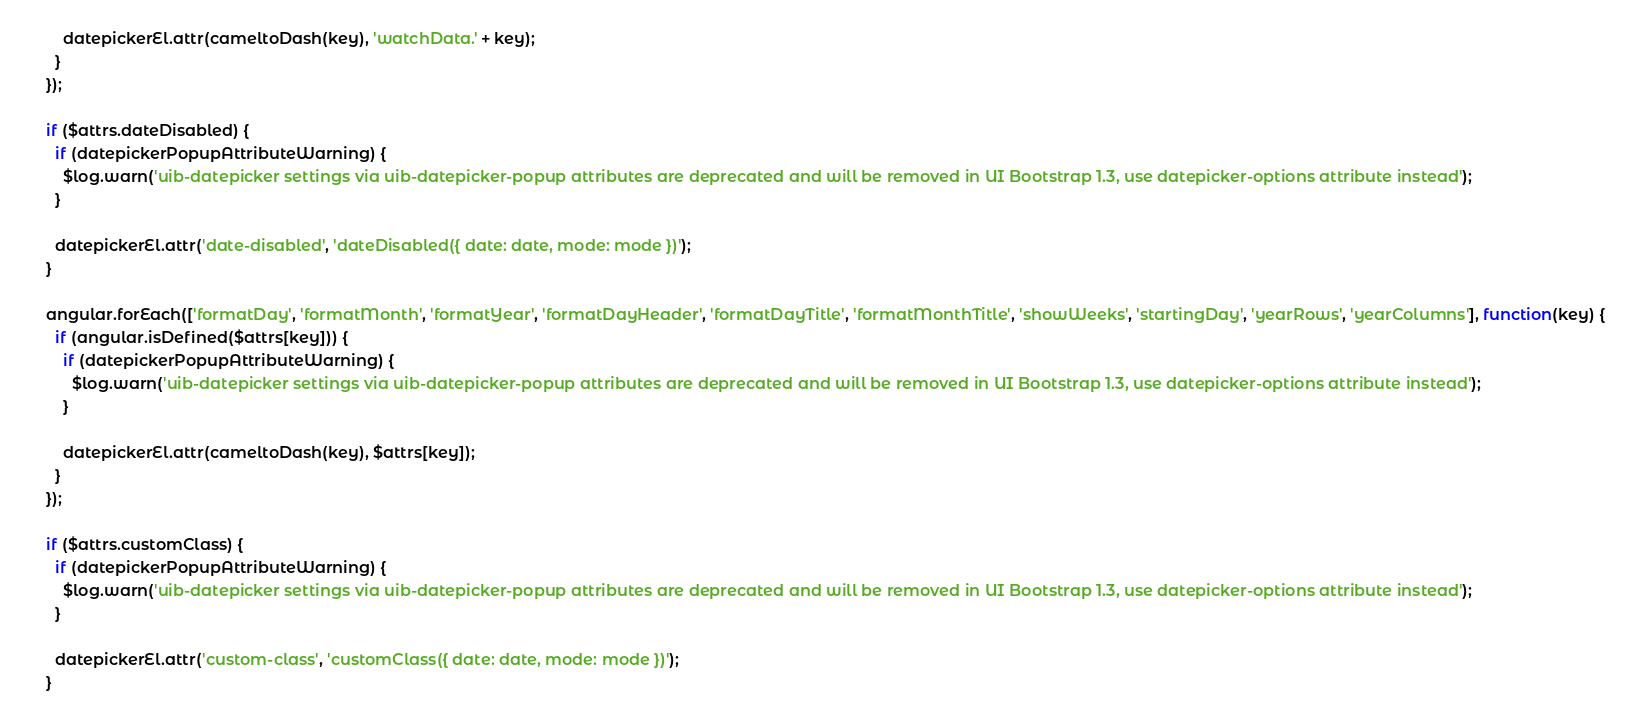<code> <loc_0><loc_0><loc_500><loc_500><_JavaScript_>        datepickerEl.attr(cameltoDash(key), 'watchData.' + key);
      }
    });

    if ($attrs.dateDisabled) {
      if (datepickerPopupAttributeWarning) {
        $log.warn('uib-datepicker settings via uib-datepicker-popup attributes are deprecated and will be removed in UI Bootstrap 1.3, use datepicker-options attribute instead');
      }

      datepickerEl.attr('date-disabled', 'dateDisabled({ date: date, mode: mode })');
    }

    angular.forEach(['formatDay', 'formatMonth', 'formatYear', 'formatDayHeader', 'formatDayTitle', 'formatMonthTitle', 'showWeeks', 'startingDay', 'yearRows', 'yearColumns'], function(key) {
      if (angular.isDefined($attrs[key])) {
        if (datepickerPopupAttributeWarning) {
          $log.warn('uib-datepicker settings via uib-datepicker-popup attributes are deprecated and will be removed in UI Bootstrap 1.3, use datepicker-options attribute instead');
        }

        datepickerEl.attr(cameltoDash(key), $attrs[key]);
      }
    });

    if ($attrs.customClass) {
      if (datepickerPopupAttributeWarning) {
        $log.warn('uib-datepicker settings via uib-datepicker-popup attributes are deprecated and will be removed in UI Bootstrap 1.3, use datepicker-options attribute instead');
      }

      datepickerEl.attr('custom-class', 'customClass({ date: date, mode: mode })');
    }
</code> 